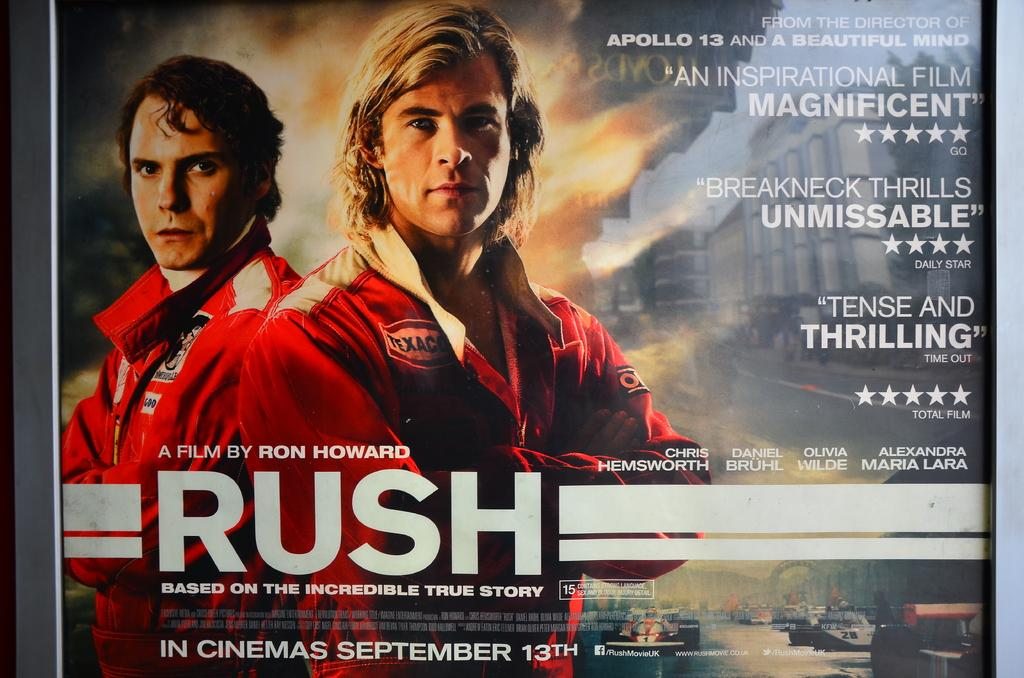<image>
Offer a succinct explanation of the picture presented. Movie poster showing two men folding their arms titled "Rush". 